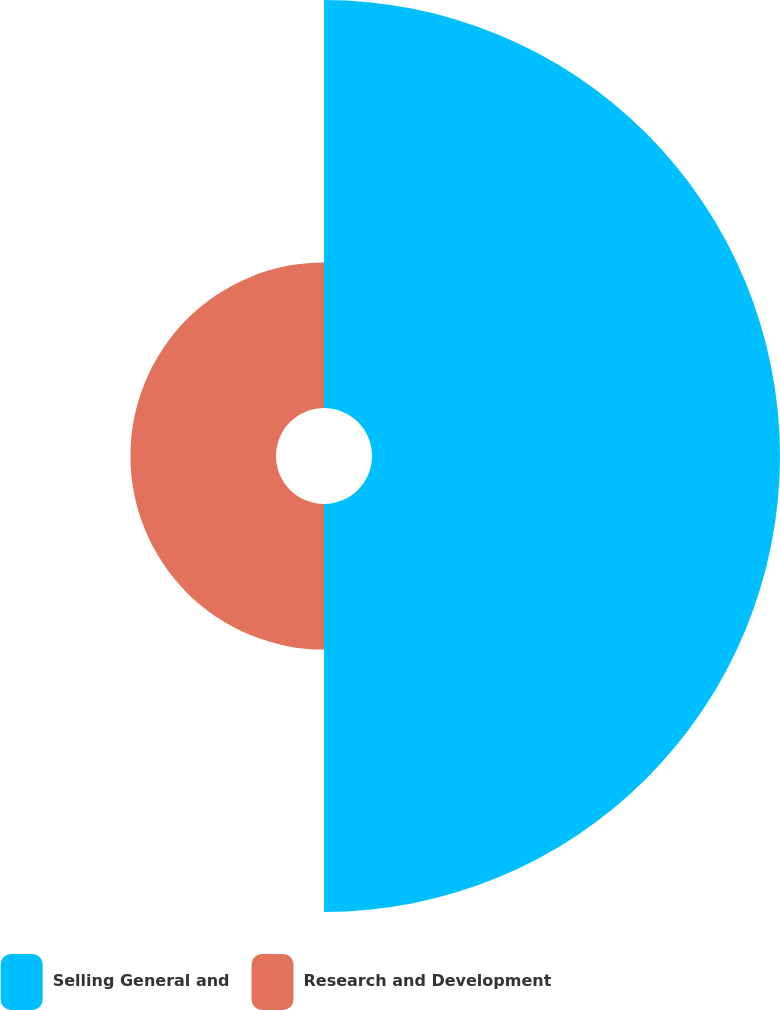Convert chart. <chart><loc_0><loc_0><loc_500><loc_500><pie_chart><fcel>Selling General and<fcel>Research and Development<nl><fcel>73.7%<fcel>26.3%<nl></chart> 